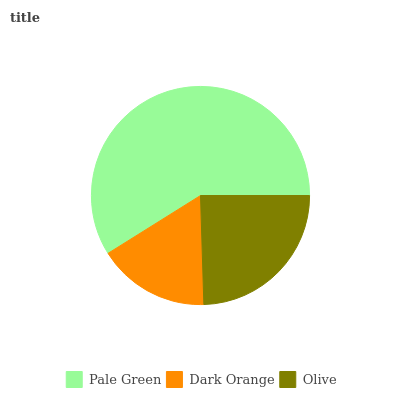Is Dark Orange the minimum?
Answer yes or no. Yes. Is Pale Green the maximum?
Answer yes or no. Yes. Is Olive the minimum?
Answer yes or no. No. Is Olive the maximum?
Answer yes or no. No. Is Olive greater than Dark Orange?
Answer yes or no. Yes. Is Dark Orange less than Olive?
Answer yes or no. Yes. Is Dark Orange greater than Olive?
Answer yes or no. No. Is Olive less than Dark Orange?
Answer yes or no. No. Is Olive the high median?
Answer yes or no. Yes. Is Olive the low median?
Answer yes or no. Yes. Is Dark Orange the high median?
Answer yes or no. No. Is Dark Orange the low median?
Answer yes or no. No. 